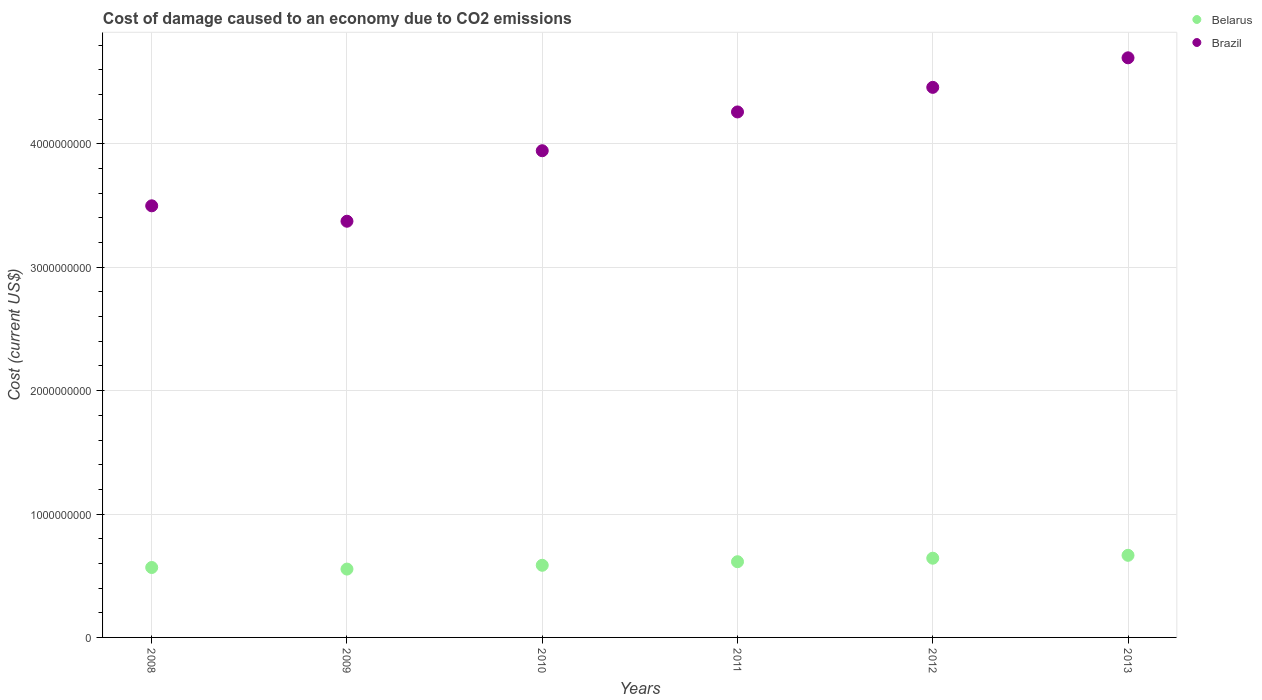How many different coloured dotlines are there?
Ensure brevity in your answer.  2. What is the cost of damage caused due to CO2 emissisons in Brazil in 2013?
Provide a short and direct response. 4.70e+09. Across all years, what is the maximum cost of damage caused due to CO2 emissisons in Brazil?
Ensure brevity in your answer.  4.70e+09. Across all years, what is the minimum cost of damage caused due to CO2 emissisons in Belarus?
Offer a very short reply. 5.54e+08. In which year was the cost of damage caused due to CO2 emissisons in Belarus maximum?
Offer a very short reply. 2013. In which year was the cost of damage caused due to CO2 emissisons in Brazil minimum?
Provide a short and direct response. 2009. What is the total cost of damage caused due to CO2 emissisons in Belarus in the graph?
Make the answer very short. 3.63e+09. What is the difference between the cost of damage caused due to CO2 emissisons in Brazil in 2010 and that in 2011?
Make the answer very short. -3.14e+08. What is the difference between the cost of damage caused due to CO2 emissisons in Brazil in 2011 and the cost of damage caused due to CO2 emissisons in Belarus in 2013?
Give a very brief answer. 3.59e+09. What is the average cost of damage caused due to CO2 emissisons in Brazil per year?
Make the answer very short. 4.04e+09. In the year 2011, what is the difference between the cost of damage caused due to CO2 emissisons in Belarus and cost of damage caused due to CO2 emissisons in Brazil?
Ensure brevity in your answer.  -3.65e+09. In how many years, is the cost of damage caused due to CO2 emissisons in Belarus greater than 800000000 US$?
Your answer should be very brief. 0. What is the ratio of the cost of damage caused due to CO2 emissisons in Belarus in 2011 to that in 2013?
Your response must be concise. 0.92. Is the difference between the cost of damage caused due to CO2 emissisons in Belarus in 2009 and 2010 greater than the difference between the cost of damage caused due to CO2 emissisons in Brazil in 2009 and 2010?
Offer a very short reply. Yes. What is the difference between the highest and the second highest cost of damage caused due to CO2 emissisons in Brazil?
Give a very brief answer. 2.39e+08. What is the difference between the highest and the lowest cost of damage caused due to CO2 emissisons in Belarus?
Ensure brevity in your answer.  1.12e+08. Is the sum of the cost of damage caused due to CO2 emissisons in Brazil in 2009 and 2011 greater than the maximum cost of damage caused due to CO2 emissisons in Belarus across all years?
Keep it short and to the point. Yes. Is the cost of damage caused due to CO2 emissisons in Brazil strictly less than the cost of damage caused due to CO2 emissisons in Belarus over the years?
Your answer should be compact. No. What is the difference between two consecutive major ticks on the Y-axis?
Your response must be concise. 1.00e+09. Are the values on the major ticks of Y-axis written in scientific E-notation?
Make the answer very short. No. Does the graph contain any zero values?
Keep it short and to the point. No. Does the graph contain grids?
Make the answer very short. Yes. Where does the legend appear in the graph?
Keep it short and to the point. Top right. What is the title of the graph?
Offer a terse response. Cost of damage caused to an economy due to CO2 emissions. Does "Papua New Guinea" appear as one of the legend labels in the graph?
Your response must be concise. No. What is the label or title of the X-axis?
Your answer should be very brief. Years. What is the label or title of the Y-axis?
Your response must be concise. Cost (current US$). What is the Cost (current US$) of Belarus in 2008?
Offer a terse response. 5.67e+08. What is the Cost (current US$) in Brazil in 2008?
Your response must be concise. 3.50e+09. What is the Cost (current US$) of Belarus in 2009?
Your response must be concise. 5.54e+08. What is the Cost (current US$) of Brazil in 2009?
Provide a succinct answer. 3.37e+09. What is the Cost (current US$) of Belarus in 2010?
Offer a very short reply. 5.85e+08. What is the Cost (current US$) in Brazil in 2010?
Your answer should be very brief. 3.94e+09. What is the Cost (current US$) in Belarus in 2011?
Your response must be concise. 6.14e+08. What is the Cost (current US$) of Brazil in 2011?
Your answer should be compact. 4.26e+09. What is the Cost (current US$) of Belarus in 2012?
Offer a very short reply. 6.42e+08. What is the Cost (current US$) of Brazil in 2012?
Your answer should be very brief. 4.46e+09. What is the Cost (current US$) in Belarus in 2013?
Your answer should be very brief. 6.66e+08. What is the Cost (current US$) of Brazil in 2013?
Ensure brevity in your answer.  4.70e+09. Across all years, what is the maximum Cost (current US$) of Belarus?
Give a very brief answer. 6.66e+08. Across all years, what is the maximum Cost (current US$) in Brazil?
Ensure brevity in your answer.  4.70e+09. Across all years, what is the minimum Cost (current US$) in Belarus?
Your response must be concise. 5.54e+08. Across all years, what is the minimum Cost (current US$) of Brazil?
Keep it short and to the point. 3.37e+09. What is the total Cost (current US$) in Belarus in the graph?
Give a very brief answer. 3.63e+09. What is the total Cost (current US$) of Brazil in the graph?
Offer a terse response. 2.42e+1. What is the difference between the Cost (current US$) of Belarus in 2008 and that in 2009?
Provide a short and direct response. 1.29e+07. What is the difference between the Cost (current US$) in Brazil in 2008 and that in 2009?
Provide a succinct answer. 1.25e+08. What is the difference between the Cost (current US$) of Belarus in 2008 and that in 2010?
Make the answer very short. -1.79e+07. What is the difference between the Cost (current US$) in Brazil in 2008 and that in 2010?
Keep it short and to the point. -4.47e+08. What is the difference between the Cost (current US$) in Belarus in 2008 and that in 2011?
Your answer should be very brief. -4.68e+07. What is the difference between the Cost (current US$) in Brazil in 2008 and that in 2011?
Offer a terse response. -7.61e+08. What is the difference between the Cost (current US$) in Belarus in 2008 and that in 2012?
Provide a succinct answer. -7.53e+07. What is the difference between the Cost (current US$) in Brazil in 2008 and that in 2012?
Your response must be concise. -9.60e+08. What is the difference between the Cost (current US$) of Belarus in 2008 and that in 2013?
Your response must be concise. -9.88e+07. What is the difference between the Cost (current US$) of Brazil in 2008 and that in 2013?
Offer a terse response. -1.20e+09. What is the difference between the Cost (current US$) of Belarus in 2009 and that in 2010?
Your answer should be very brief. -3.08e+07. What is the difference between the Cost (current US$) in Brazil in 2009 and that in 2010?
Offer a terse response. -5.71e+08. What is the difference between the Cost (current US$) in Belarus in 2009 and that in 2011?
Your answer should be compact. -5.96e+07. What is the difference between the Cost (current US$) in Brazil in 2009 and that in 2011?
Your response must be concise. -8.86e+08. What is the difference between the Cost (current US$) of Belarus in 2009 and that in 2012?
Your response must be concise. -8.81e+07. What is the difference between the Cost (current US$) in Brazil in 2009 and that in 2012?
Provide a succinct answer. -1.09e+09. What is the difference between the Cost (current US$) in Belarus in 2009 and that in 2013?
Offer a very short reply. -1.12e+08. What is the difference between the Cost (current US$) of Brazil in 2009 and that in 2013?
Your answer should be compact. -1.32e+09. What is the difference between the Cost (current US$) of Belarus in 2010 and that in 2011?
Ensure brevity in your answer.  -2.88e+07. What is the difference between the Cost (current US$) in Brazil in 2010 and that in 2011?
Make the answer very short. -3.14e+08. What is the difference between the Cost (current US$) of Belarus in 2010 and that in 2012?
Your answer should be compact. -5.73e+07. What is the difference between the Cost (current US$) in Brazil in 2010 and that in 2012?
Keep it short and to the point. -5.14e+08. What is the difference between the Cost (current US$) of Belarus in 2010 and that in 2013?
Your response must be concise. -8.08e+07. What is the difference between the Cost (current US$) of Brazil in 2010 and that in 2013?
Your response must be concise. -7.53e+08. What is the difference between the Cost (current US$) in Belarus in 2011 and that in 2012?
Ensure brevity in your answer.  -2.85e+07. What is the difference between the Cost (current US$) in Brazil in 2011 and that in 2012?
Your answer should be compact. -1.99e+08. What is the difference between the Cost (current US$) in Belarus in 2011 and that in 2013?
Provide a succinct answer. -5.20e+07. What is the difference between the Cost (current US$) of Brazil in 2011 and that in 2013?
Your response must be concise. -4.39e+08. What is the difference between the Cost (current US$) in Belarus in 2012 and that in 2013?
Your answer should be very brief. -2.35e+07. What is the difference between the Cost (current US$) of Brazil in 2012 and that in 2013?
Your answer should be compact. -2.39e+08. What is the difference between the Cost (current US$) of Belarus in 2008 and the Cost (current US$) of Brazil in 2009?
Your answer should be compact. -2.81e+09. What is the difference between the Cost (current US$) in Belarus in 2008 and the Cost (current US$) in Brazil in 2010?
Keep it short and to the point. -3.38e+09. What is the difference between the Cost (current US$) in Belarus in 2008 and the Cost (current US$) in Brazil in 2011?
Make the answer very short. -3.69e+09. What is the difference between the Cost (current US$) of Belarus in 2008 and the Cost (current US$) of Brazil in 2012?
Provide a short and direct response. -3.89e+09. What is the difference between the Cost (current US$) in Belarus in 2008 and the Cost (current US$) in Brazil in 2013?
Your answer should be very brief. -4.13e+09. What is the difference between the Cost (current US$) in Belarus in 2009 and the Cost (current US$) in Brazil in 2010?
Your answer should be very brief. -3.39e+09. What is the difference between the Cost (current US$) in Belarus in 2009 and the Cost (current US$) in Brazil in 2011?
Provide a succinct answer. -3.71e+09. What is the difference between the Cost (current US$) in Belarus in 2009 and the Cost (current US$) in Brazil in 2012?
Offer a very short reply. -3.90e+09. What is the difference between the Cost (current US$) in Belarus in 2009 and the Cost (current US$) in Brazil in 2013?
Make the answer very short. -4.14e+09. What is the difference between the Cost (current US$) in Belarus in 2010 and the Cost (current US$) in Brazil in 2011?
Provide a succinct answer. -3.67e+09. What is the difference between the Cost (current US$) of Belarus in 2010 and the Cost (current US$) of Brazil in 2012?
Offer a very short reply. -3.87e+09. What is the difference between the Cost (current US$) in Belarus in 2010 and the Cost (current US$) in Brazil in 2013?
Offer a terse response. -4.11e+09. What is the difference between the Cost (current US$) in Belarus in 2011 and the Cost (current US$) in Brazil in 2012?
Your answer should be compact. -3.84e+09. What is the difference between the Cost (current US$) of Belarus in 2011 and the Cost (current US$) of Brazil in 2013?
Provide a short and direct response. -4.08e+09. What is the difference between the Cost (current US$) of Belarus in 2012 and the Cost (current US$) of Brazil in 2013?
Your answer should be very brief. -4.06e+09. What is the average Cost (current US$) of Belarus per year?
Your answer should be compact. 6.04e+08. What is the average Cost (current US$) of Brazil per year?
Your answer should be compact. 4.04e+09. In the year 2008, what is the difference between the Cost (current US$) in Belarus and Cost (current US$) in Brazil?
Your response must be concise. -2.93e+09. In the year 2009, what is the difference between the Cost (current US$) of Belarus and Cost (current US$) of Brazil?
Provide a short and direct response. -2.82e+09. In the year 2010, what is the difference between the Cost (current US$) in Belarus and Cost (current US$) in Brazil?
Provide a succinct answer. -3.36e+09. In the year 2011, what is the difference between the Cost (current US$) of Belarus and Cost (current US$) of Brazil?
Ensure brevity in your answer.  -3.65e+09. In the year 2012, what is the difference between the Cost (current US$) in Belarus and Cost (current US$) in Brazil?
Keep it short and to the point. -3.82e+09. In the year 2013, what is the difference between the Cost (current US$) in Belarus and Cost (current US$) in Brazil?
Offer a terse response. -4.03e+09. What is the ratio of the Cost (current US$) of Belarus in 2008 to that in 2009?
Ensure brevity in your answer.  1.02. What is the ratio of the Cost (current US$) in Belarus in 2008 to that in 2010?
Your answer should be compact. 0.97. What is the ratio of the Cost (current US$) of Brazil in 2008 to that in 2010?
Keep it short and to the point. 0.89. What is the ratio of the Cost (current US$) in Belarus in 2008 to that in 2011?
Provide a short and direct response. 0.92. What is the ratio of the Cost (current US$) in Brazil in 2008 to that in 2011?
Ensure brevity in your answer.  0.82. What is the ratio of the Cost (current US$) in Belarus in 2008 to that in 2012?
Offer a terse response. 0.88. What is the ratio of the Cost (current US$) in Brazil in 2008 to that in 2012?
Ensure brevity in your answer.  0.78. What is the ratio of the Cost (current US$) of Belarus in 2008 to that in 2013?
Offer a very short reply. 0.85. What is the ratio of the Cost (current US$) in Brazil in 2008 to that in 2013?
Your answer should be very brief. 0.74. What is the ratio of the Cost (current US$) in Belarus in 2009 to that in 2010?
Make the answer very short. 0.95. What is the ratio of the Cost (current US$) in Brazil in 2009 to that in 2010?
Keep it short and to the point. 0.86. What is the ratio of the Cost (current US$) in Belarus in 2009 to that in 2011?
Your answer should be compact. 0.9. What is the ratio of the Cost (current US$) of Brazil in 2009 to that in 2011?
Your answer should be compact. 0.79. What is the ratio of the Cost (current US$) of Belarus in 2009 to that in 2012?
Your response must be concise. 0.86. What is the ratio of the Cost (current US$) in Brazil in 2009 to that in 2012?
Your response must be concise. 0.76. What is the ratio of the Cost (current US$) of Belarus in 2009 to that in 2013?
Offer a very short reply. 0.83. What is the ratio of the Cost (current US$) in Brazil in 2009 to that in 2013?
Offer a terse response. 0.72. What is the ratio of the Cost (current US$) in Belarus in 2010 to that in 2011?
Provide a short and direct response. 0.95. What is the ratio of the Cost (current US$) of Brazil in 2010 to that in 2011?
Your response must be concise. 0.93. What is the ratio of the Cost (current US$) in Belarus in 2010 to that in 2012?
Ensure brevity in your answer.  0.91. What is the ratio of the Cost (current US$) of Brazil in 2010 to that in 2012?
Ensure brevity in your answer.  0.88. What is the ratio of the Cost (current US$) of Belarus in 2010 to that in 2013?
Give a very brief answer. 0.88. What is the ratio of the Cost (current US$) of Brazil in 2010 to that in 2013?
Offer a terse response. 0.84. What is the ratio of the Cost (current US$) in Belarus in 2011 to that in 2012?
Offer a terse response. 0.96. What is the ratio of the Cost (current US$) of Brazil in 2011 to that in 2012?
Give a very brief answer. 0.96. What is the ratio of the Cost (current US$) of Belarus in 2011 to that in 2013?
Provide a succinct answer. 0.92. What is the ratio of the Cost (current US$) of Brazil in 2011 to that in 2013?
Offer a terse response. 0.91. What is the ratio of the Cost (current US$) of Belarus in 2012 to that in 2013?
Provide a short and direct response. 0.96. What is the ratio of the Cost (current US$) in Brazil in 2012 to that in 2013?
Make the answer very short. 0.95. What is the difference between the highest and the second highest Cost (current US$) in Belarus?
Offer a very short reply. 2.35e+07. What is the difference between the highest and the second highest Cost (current US$) of Brazil?
Provide a succinct answer. 2.39e+08. What is the difference between the highest and the lowest Cost (current US$) in Belarus?
Ensure brevity in your answer.  1.12e+08. What is the difference between the highest and the lowest Cost (current US$) in Brazil?
Your answer should be very brief. 1.32e+09. 